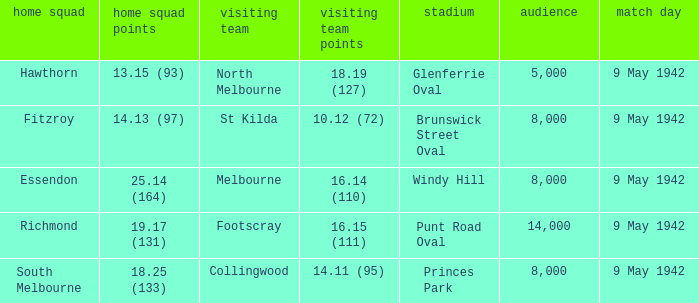How large was the crowd with a home team score of 18.25 (133)? 8000.0. 